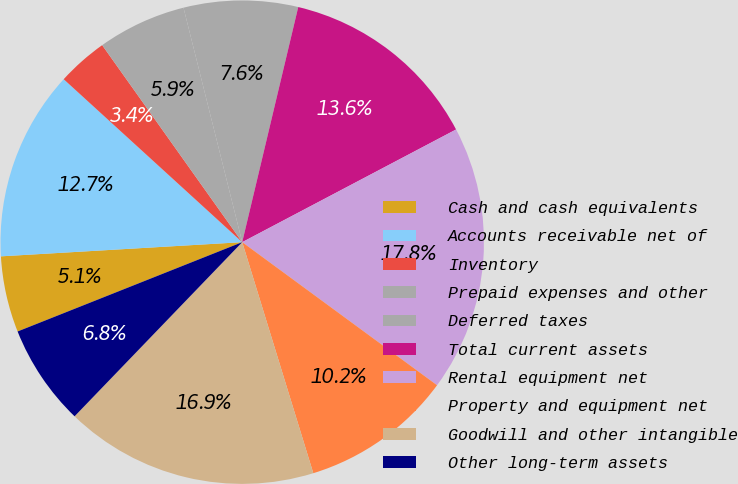<chart> <loc_0><loc_0><loc_500><loc_500><pie_chart><fcel>Cash and cash equivalents<fcel>Accounts receivable net of<fcel>Inventory<fcel>Prepaid expenses and other<fcel>Deferred taxes<fcel>Total current assets<fcel>Rental equipment net<fcel>Property and equipment net<fcel>Goodwill and other intangible<fcel>Other long-term assets<nl><fcel>5.09%<fcel>12.71%<fcel>3.39%<fcel>5.93%<fcel>7.63%<fcel>13.56%<fcel>17.8%<fcel>10.17%<fcel>16.95%<fcel>6.78%<nl></chart> 